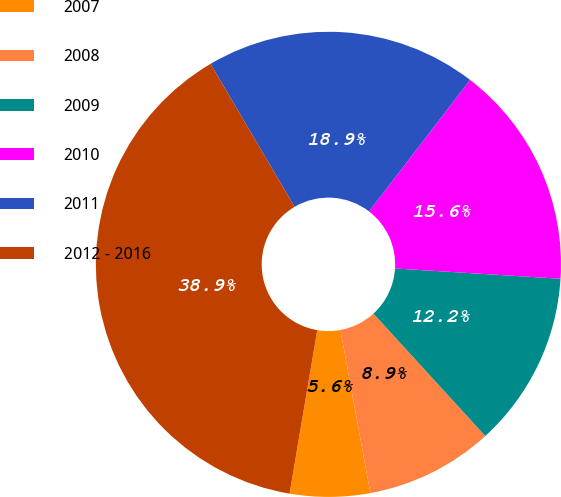<chart> <loc_0><loc_0><loc_500><loc_500><pie_chart><fcel>2007<fcel>2008<fcel>2009<fcel>2010<fcel>2011<fcel>2012 - 2016<nl><fcel>5.56%<fcel>8.9%<fcel>12.23%<fcel>15.56%<fcel>18.89%<fcel>38.87%<nl></chart> 